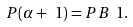Convert formula to latex. <formula><loc_0><loc_0><loc_500><loc_500>P ( \alpha + \ 1 ) = P B \ 1 .</formula> 